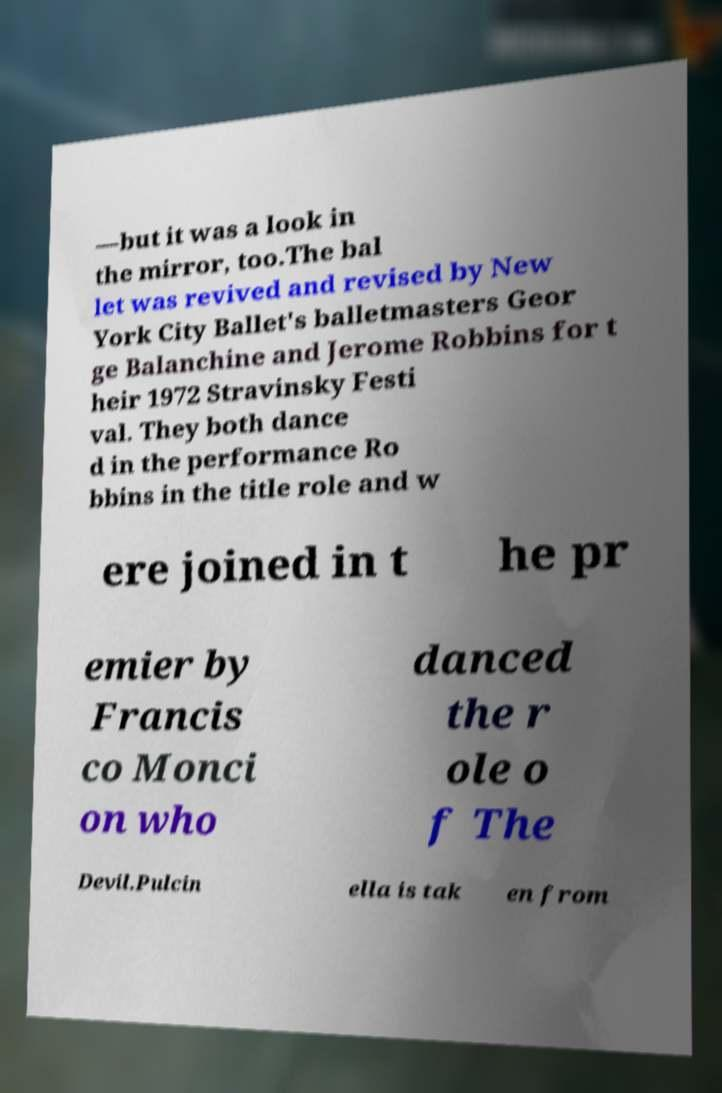Can you read and provide the text displayed in the image?This photo seems to have some interesting text. Can you extract and type it out for me? —but it was a look in the mirror, too.The bal let was revived and revised by New York City Ballet's balletmasters Geor ge Balanchine and Jerome Robbins for t heir 1972 Stravinsky Festi val. They both dance d in the performance Ro bbins in the title role and w ere joined in t he pr emier by Francis co Monci on who danced the r ole o f The Devil.Pulcin ella is tak en from 